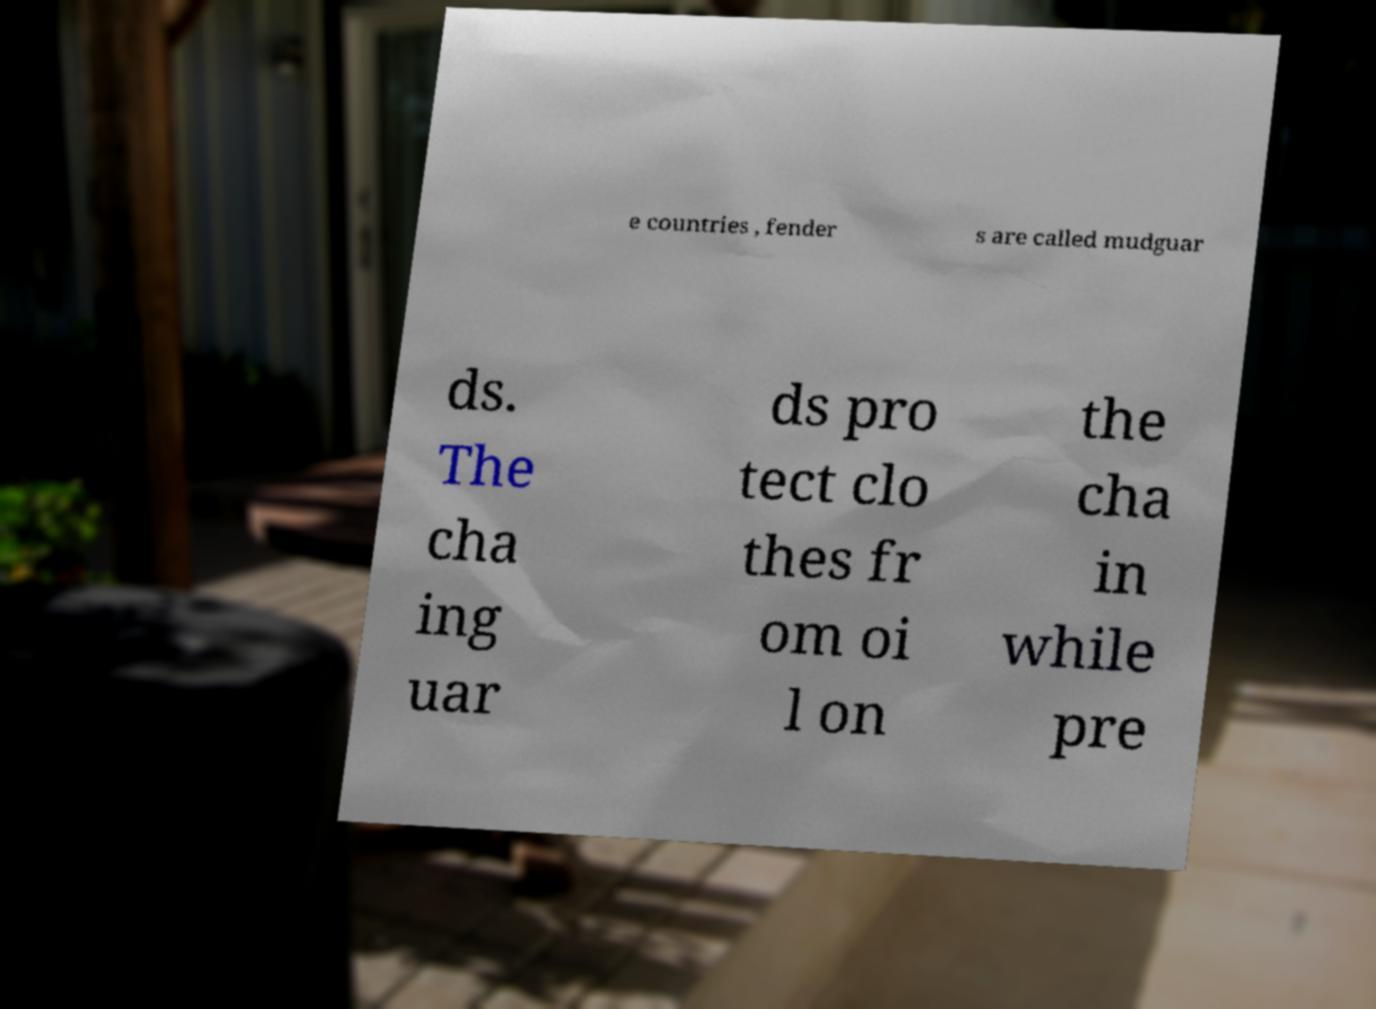What messages or text are displayed in this image? I need them in a readable, typed format. e countries , fender s are called mudguar ds. The cha ing uar ds pro tect clo thes fr om oi l on the cha in while pre 